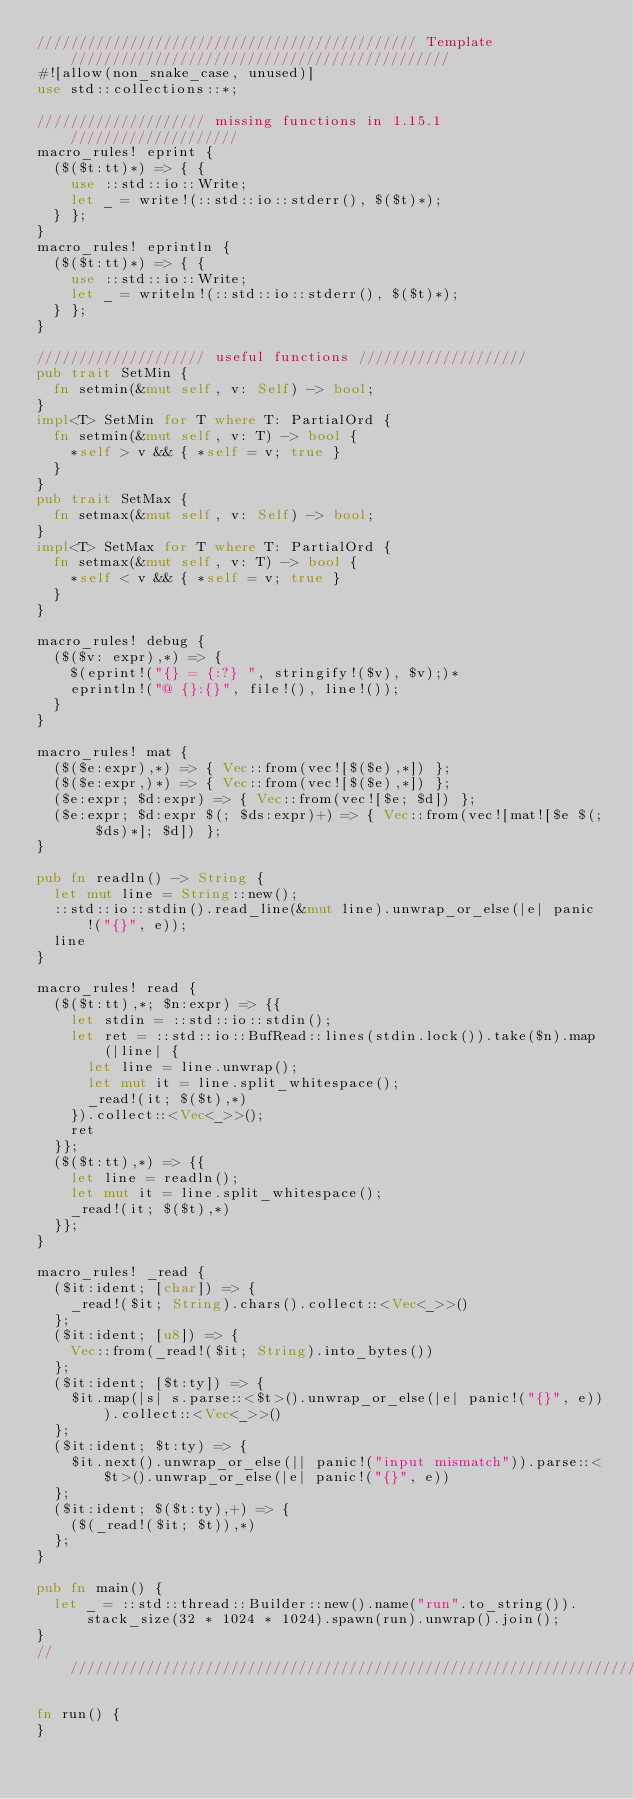Convert code to text. <code><loc_0><loc_0><loc_500><loc_500><_Rust_>///////////////////////////////////////////// Template /////////////////////////////////////////////
#![allow(non_snake_case, unused)]
use std::collections::*;

//////////////////// missing functions in 1.15.1 ////////////////////
macro_rules! eprint {
	($($t:tt)*) => { {
		use ::std::io::Write;
		let _ = write!(::std::io::stderr(), $($t)*);
	} };
}
macro_rules! eprintln {
	($($t:tt)*) => { {
		use ::std::io::Write;
		let _ = writeln!(::std::io::stderr(), $($t)*);
	} };
}

//////////////////// useful functions ////////////////////
pub trait SetMin {
	fn setmin(&mut self, v: Self) -> bool;
}
impl<T> SetMin for T where T: PartialOrd {
	fn setmin(&mut self, v: T) -> bool {
		*self > v && { *self = v; true }
	}
}
pub trait SetMax {
	fn setmax(&mut self, v: Self) -> bool;
}
impl<T> SetMax for T where T: PartialOrd {
	fn setmax(&mut self, v: T) -> bool {
		*self < v && { *self = v; true }
	}
}

macro_rules! debug {
	($($v: expr),*) => {
		$(eprint!("{} = {:?} ", stringify!($v), $v);)*
		eprintln!("@ {}:{}", file!(), line!());
	}
}

macro_rules! mat {
	($($e:expr),*) => { Vec::from(vec![$($e),*]) };
	($($e:expr,)*) => { Vec::from(vec![$($e),*]) };
	($e:expr; $d:expr) => { Vec::from(vec![$e; $d]) };
	($e:expr; $d:expr $(; $ds:expr)+) => { Vec::from(vec![mat![$e $(; $ds)*]; $d]) };
}

pub fn readln() -> String {
	let mut line = String::new();
	::std::io::stdin().read_line(&mut line).unwrap_or_else(|e| panic!("{}", e));
	line
}

macro_rules! read {
	($($t:tt),*; $n:expr) => {{
		let stdin = ::std::io::stdin();
		let ret = ::std::io::BufRead::lines(stdin.lock()).take($n).map(|line| {
			let line = line.unwrap();
			let mut it = line.split_whitespace();
			_read!(it; $($t),*)
		}).collect::<Vec<_>>();
		ret
	}};
	($($t:tt),*) => {{
		let line = readln();
		let mut it = line.split_whitespace();
		_read!(it; $($t),*)
	}};
}

macro_rules! _read {
	($it:ident; [char]) => {
		_read!($it; String).chars().collect::<Vec<_>>()
	};
	($it:ident; [u8]) => {
		Vec::from(_read!($it; String).into_bytes())
	};
	($it:ident; [$t:ty]) => {
		$it.map(|s| s.parse::<$t>().unwrap_or_else(|e| panic!("{}", e))).collect::<Vec<_>>()
	};
	($it:ident; $t:ty) => {
		$it.next().unwrap_or_else(|| panic!("input mismatch")).parse::<$t>().unwrap_or_else(|e| panic!("{}", e))
	};
	($it:ident; $($t:ty),+) => {
		($(_read!($it; $t)),*)
	};
}

pub fn main() {
	let _ = ::std::thread::Builder::new().name("run".to_string()).stack_size(32 * 1024 * 1024).spawn(run).unwrap().join();
}
////////////////////////////////////////////////////////////////////////////////////////////////////

fn run() {
}
</code> 